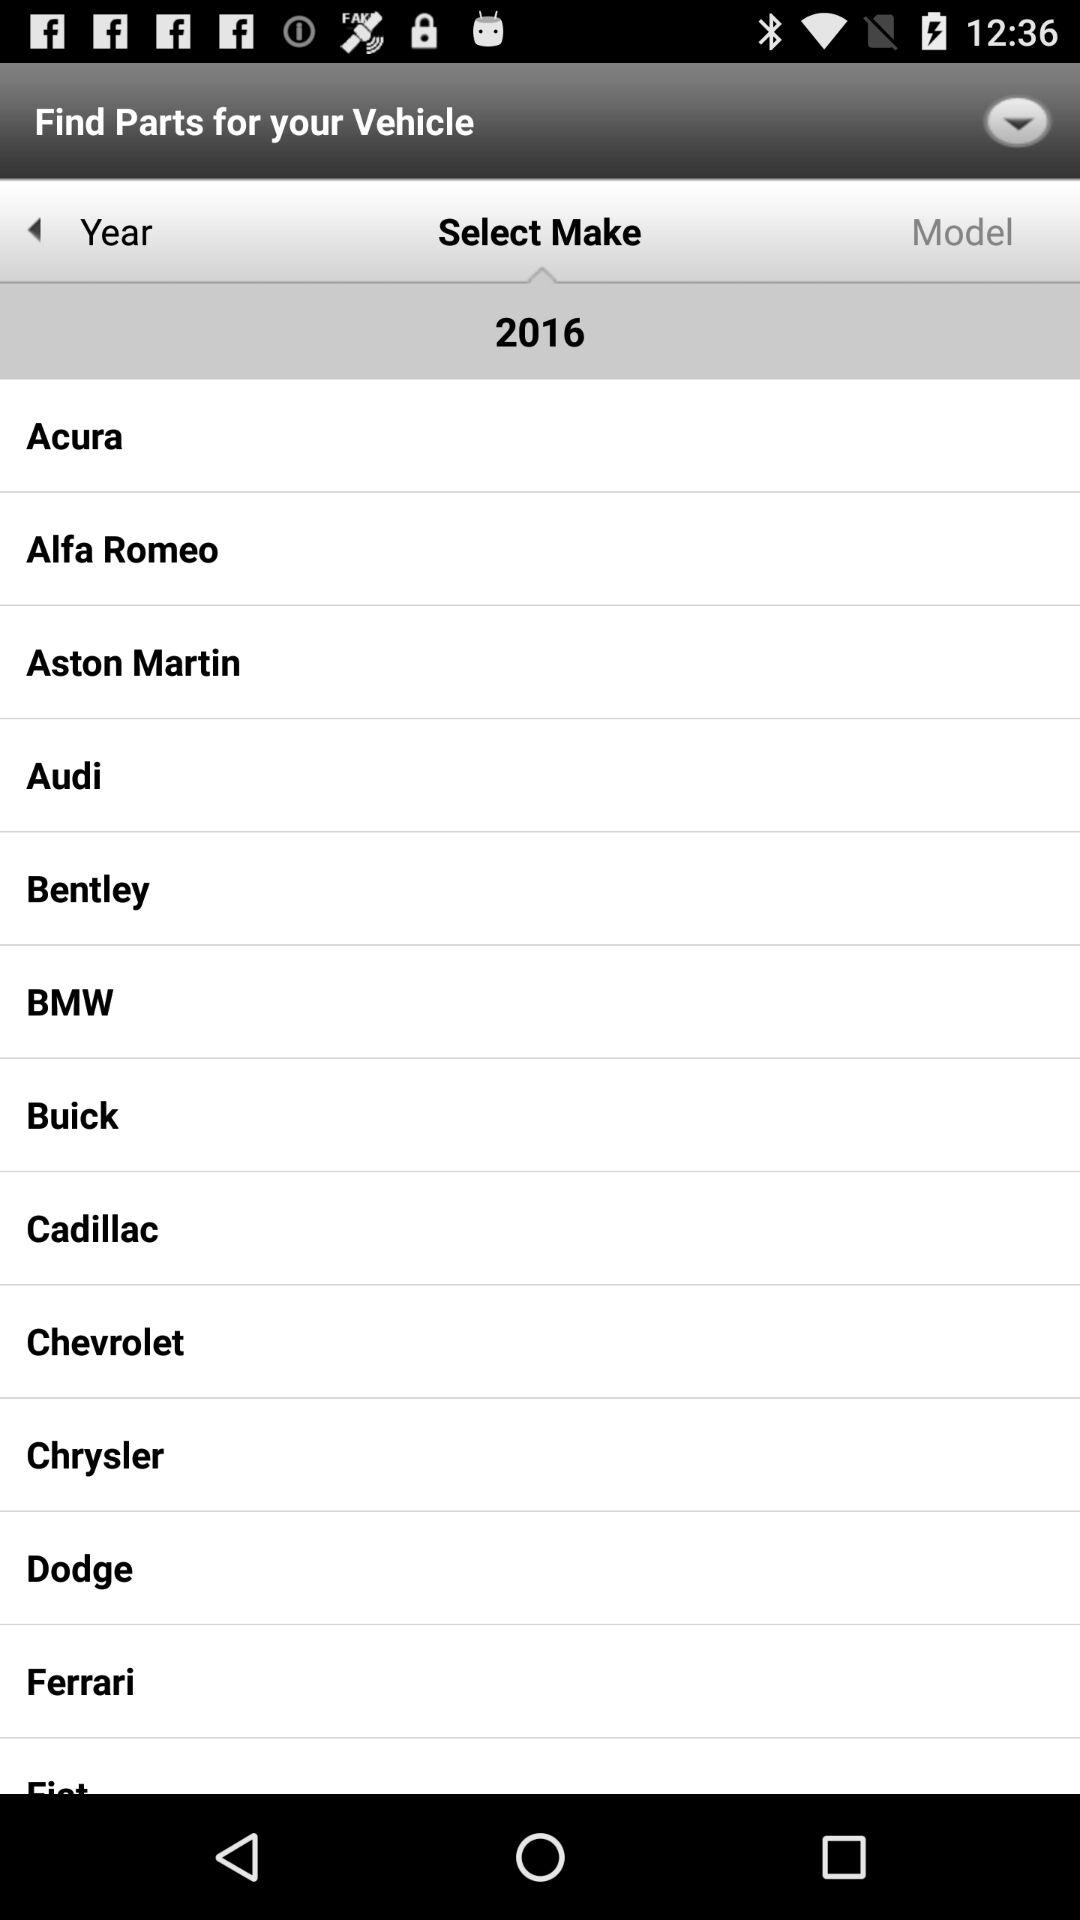Which tab is currently selected? The currently selected tab is "Select Make". 